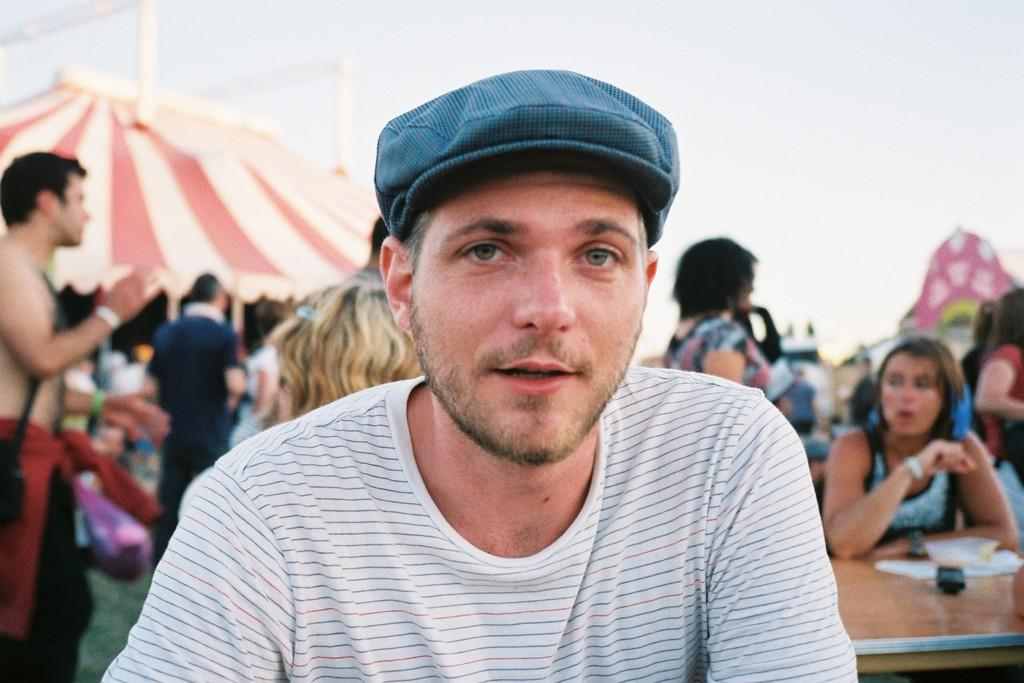What are the people in the image doing? Some people are standing, and others are seated in the image. Can you describe the clothing of one of the individuals? A man is wearing a cap in the image. What type of shelter is visible in the image? There is a tent in the image. How would you describe the weather based on the image? The sky is cloudy in the image. What items can be seen on a table in the image? Papers are on a table in the image. What type of glue is being used to hold the tent together in the image? There is no glue visible in the image, and the tent appears to be held up by poles or other supports. What month is depicted on the calendar in the image? There is no calendar present in the image. 